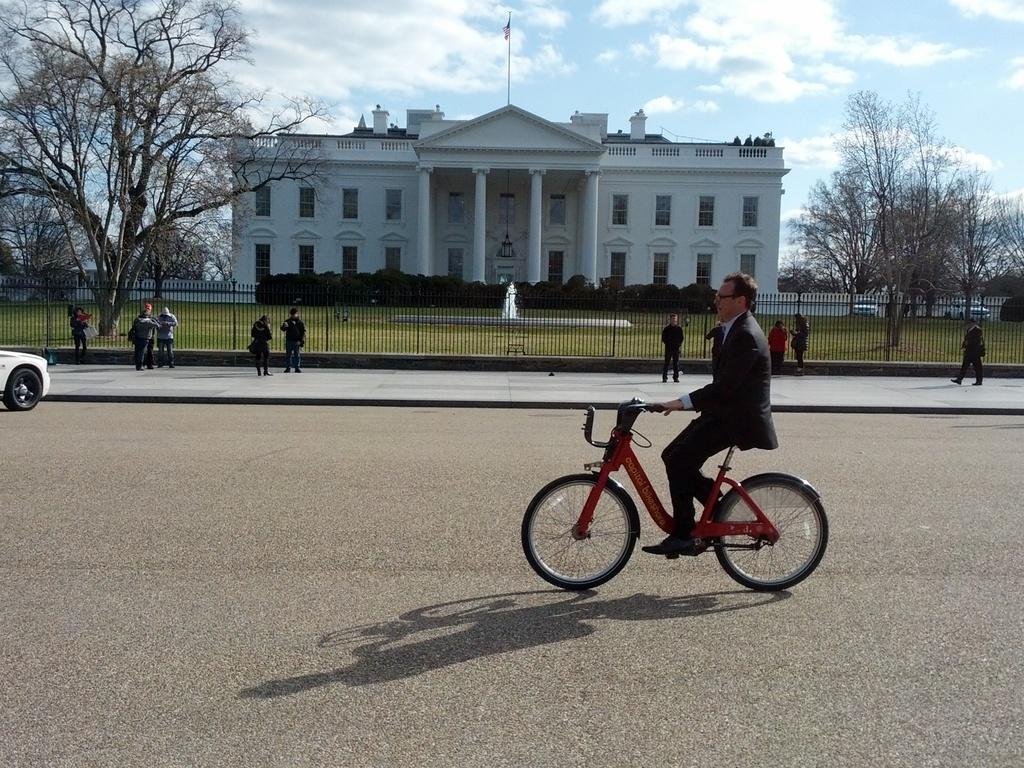Please provide a concise description of this image. In this picture a guy is riding a bicycle and there are few people standing in the background of the image. There is a beautiful white building in the background. 